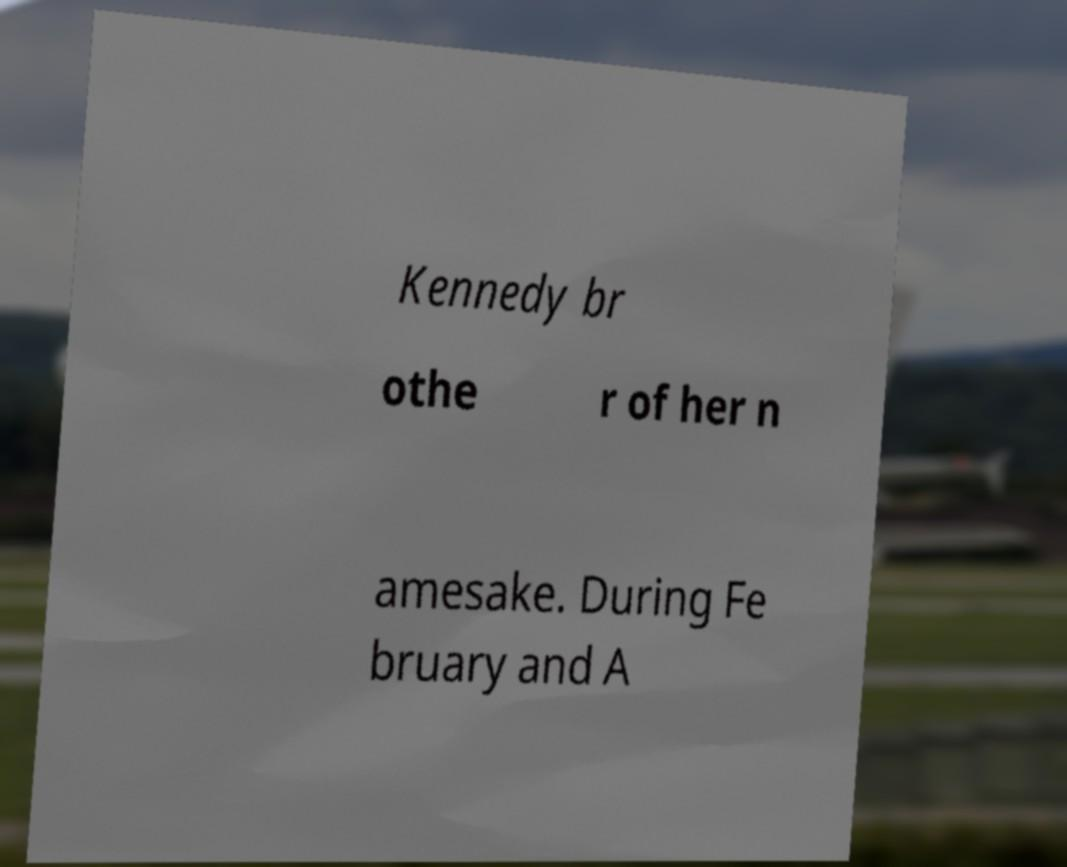Can you read and provide the text displayed in the image?This photo seems to have some interesting text. Can you extract and type it out for me? Kennedy br othe r of her n amesake. During Fe bruary and A 